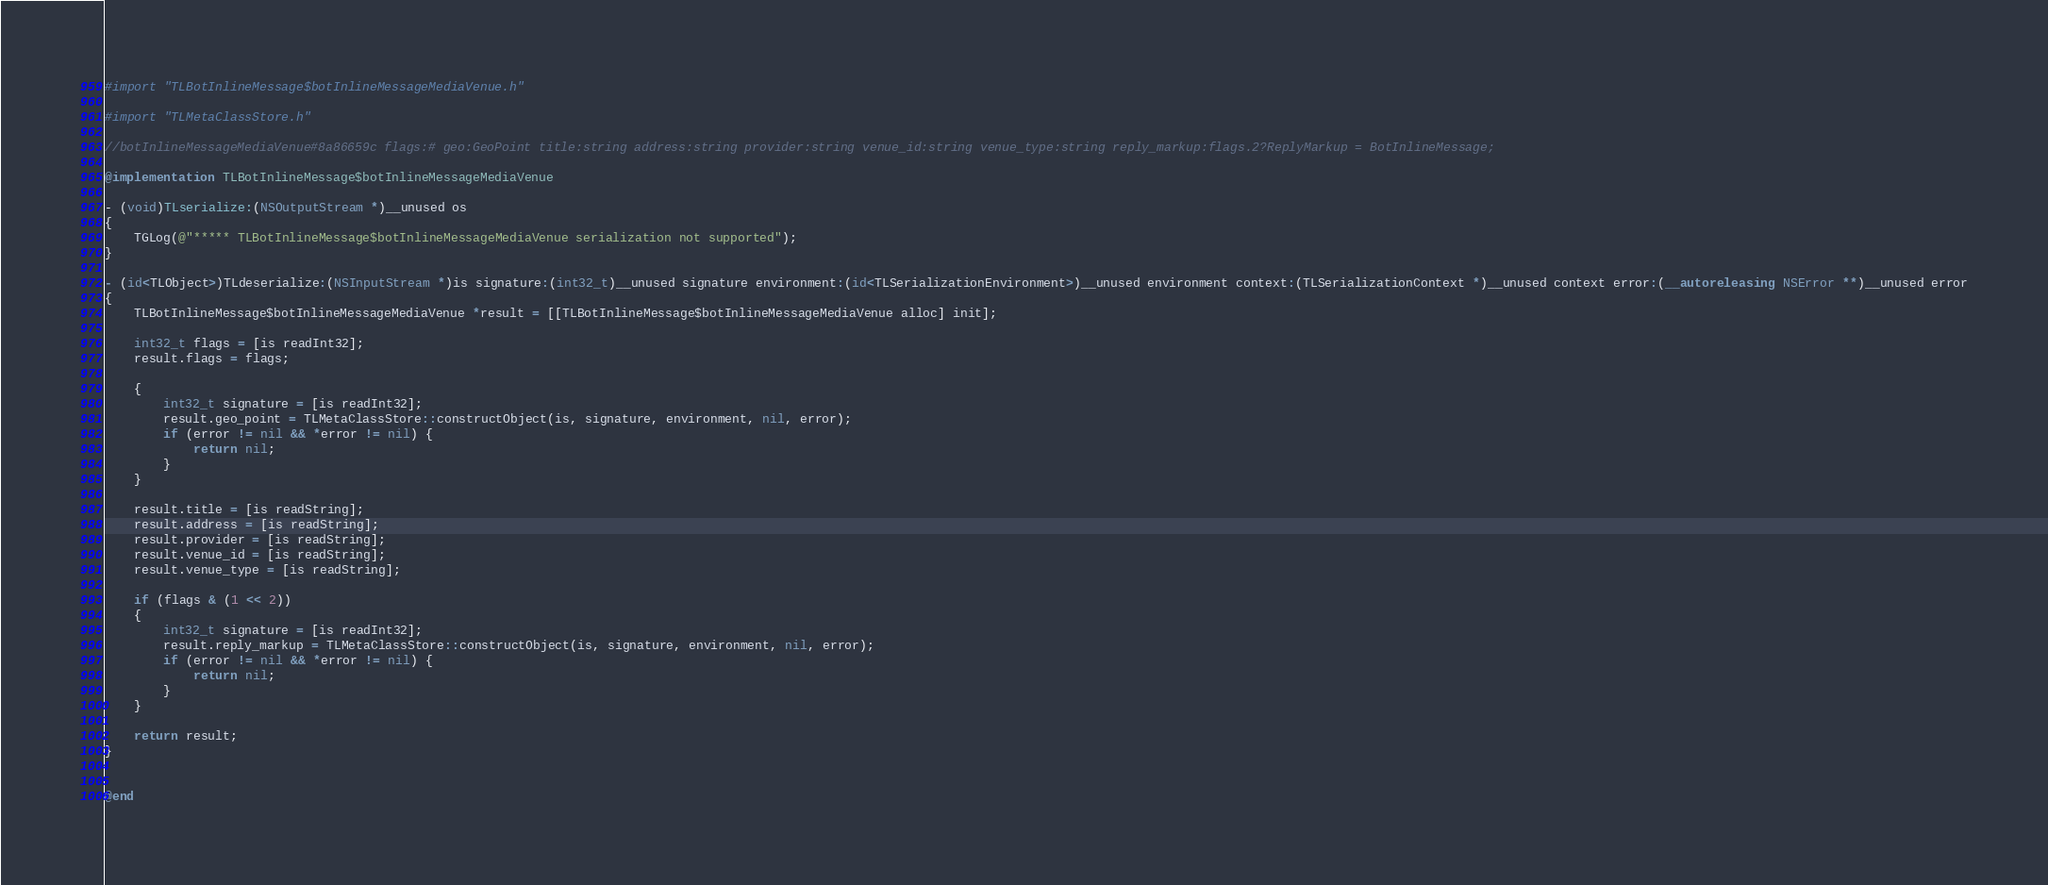<code> <loc_0><loc_0><loc_500><loc_500><_ObjectiveC_>#import "TLBotInlineMessage$botInlineMessageMediaVenue.h"

#import "TLMetaClassStore.h"

//botInlineMessageMediaVenue#8a86659c flags:# geo:GeoPoint title:string address:string provider:string venue_id:string venue_type:string reply_markup:flags.2?ReplyMarkup = BotInlineMessage;

@implementation TLBotInlineMessage$botInlineMessageMediaVenue

- (void)TLserialize:(NSOutputStream *)__unused os
{
    TGLog(@"***** TLBotInlineMessage$botInlineMessageMediaVenue serialization not supported");
}

- (id<TLObject>)TLdeserialize:(NSInputStream *)is signature:(int32_t)__unused signature environment:(id<TLSerializationEnvironment>)__unused environment context:(TLSerializationContext *)__unused context error:(__autoreleasing NSError **)__unused error
{
    TLBotInlineMessage$botInlineMessageMediaVenue *result = [[TLBotInlineMessage$botInlineMessageMediaVenue alloc] init];
    
    int32_t flags = [is readInt32];
    result.flags = flags;
    
    {
        int32_t signature = [is readInt32];
        result.geo_point = TLMetaClassStore::constructObject(is, signature, environment, nil, error);
        if (error != nil && *error != nil) {
            return nil;
        }
    }
    
    result.title = [is readString];
    result.address = [is readString];
    result.provider = [is readString];
    result.venue_id = [is readString];
    result.venue_type = [is readString];
    
    if (flags & (1 << 2))
    {
        int32_t signature = [is readInt32];
        result.reply_markup = TLMetaClassStore::constructObject(is, signature, environment, nil, error);
        if (error != nil && *error != nil) {
            return nil;
        }
    }
    
    return result;
}


@end
</code> 